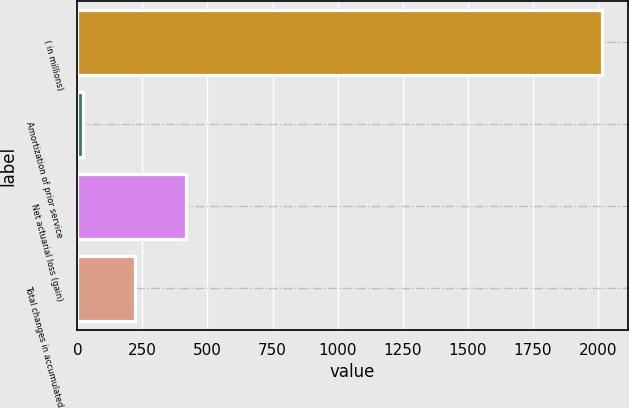Convert chart. <chart><loc_0><loc_0><loc_500><loc_500><bar_chart><fcel>( in millions)<fcel>Amortization of prior service<fcel>Net actuarial loss (gain)<fcel>Total changes in accumulated<nl><fcel>2015<fcel>20<fcel>419<fcel>219.5<nl></chart> 